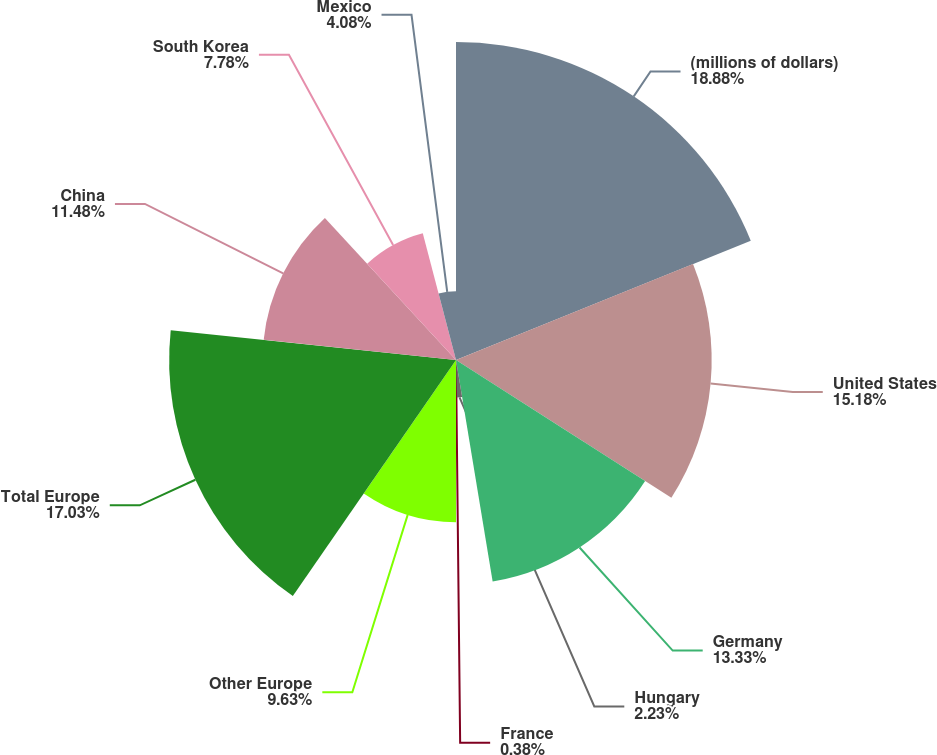Convert chart. <chart><loc_0><loc_0><loc_500><loc_500><pie_chart><fcel>(millions of dollars)<fcel>United States<fcel>Germany<fcel>Hungary<fcel>France<fcel>Other Europe<fcel>Total Europe<fcel>China<fcel>South Korea<fcel>Mexico<nl><fcel>18.88%<fcel>15.18%<fcel>13.33%<fcel>2.23%<fcel>0.38%<fcel>9.63%<fcel>17.03%<fcel>11.48%<fcel>7.78%<fcel>4.08%<nl></chart> 